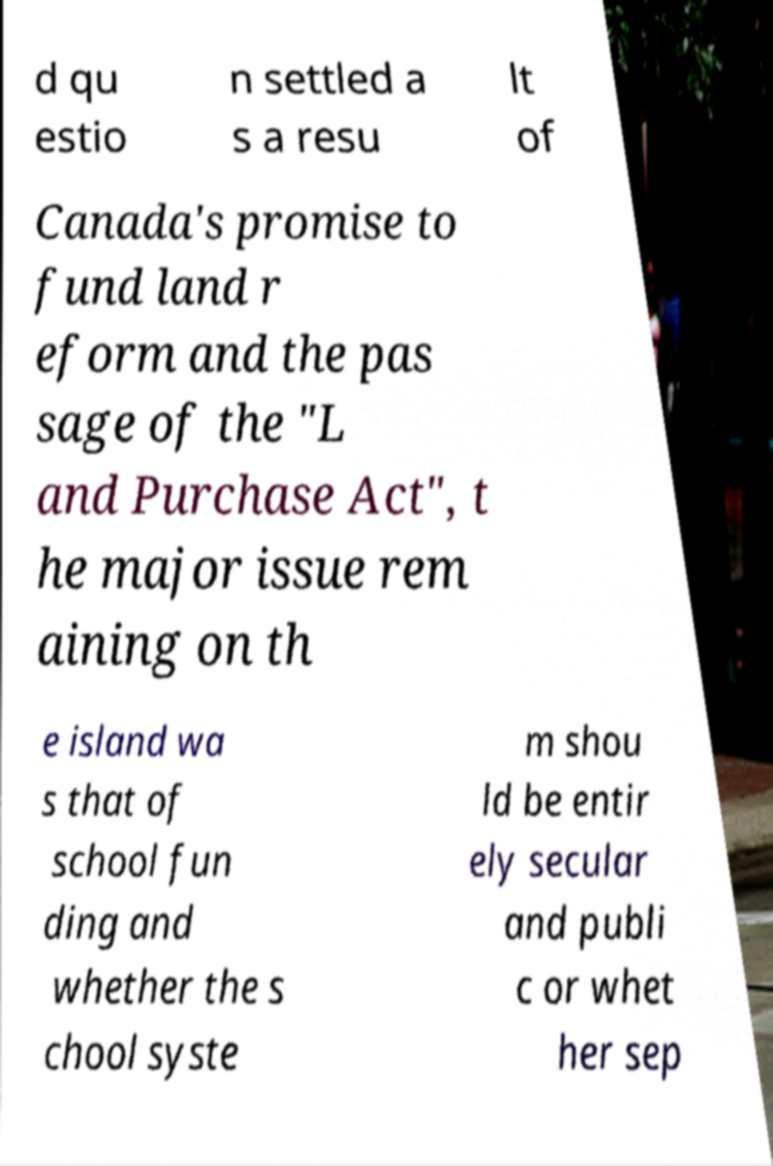There's text embedded in this image that I need extracted. Can you transcribe it verbatim? d qu estio n settled a s a resu lt of Canada's promise to fund land r eform and the pas sage of the "L and Purchase Act", t he major issue rem aining on th e island wa s that of school fun ding and whether the s chool syste m shou ld be entir ely secular and publi c or whet her sep 